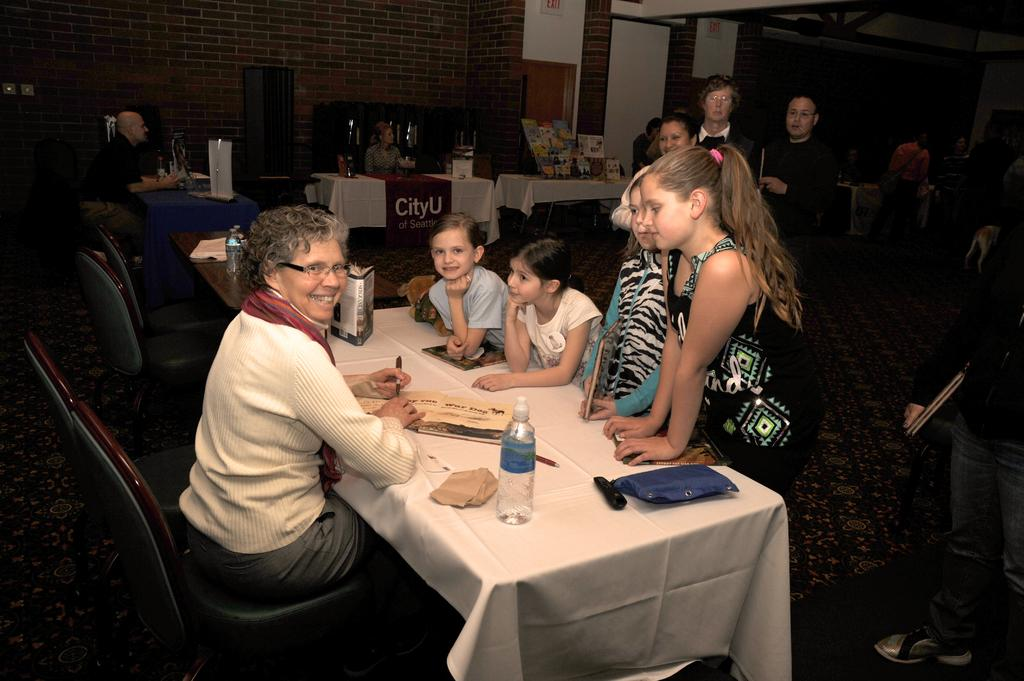How many people are in the image? There are people in the image, but the exact number is not specified. What are the people in the image doing? Some people are sitting, while others are standing. What type of furniture is present in the image? There are chairs and tables in the image. What items can be found on one of the tables? On one of the tables, there is an eye bag and a bottle. How many units of soap are visible on the table in the image? There is no soap present in the image. Are there any chickens in the image? There is no mention of chickens in the image. 